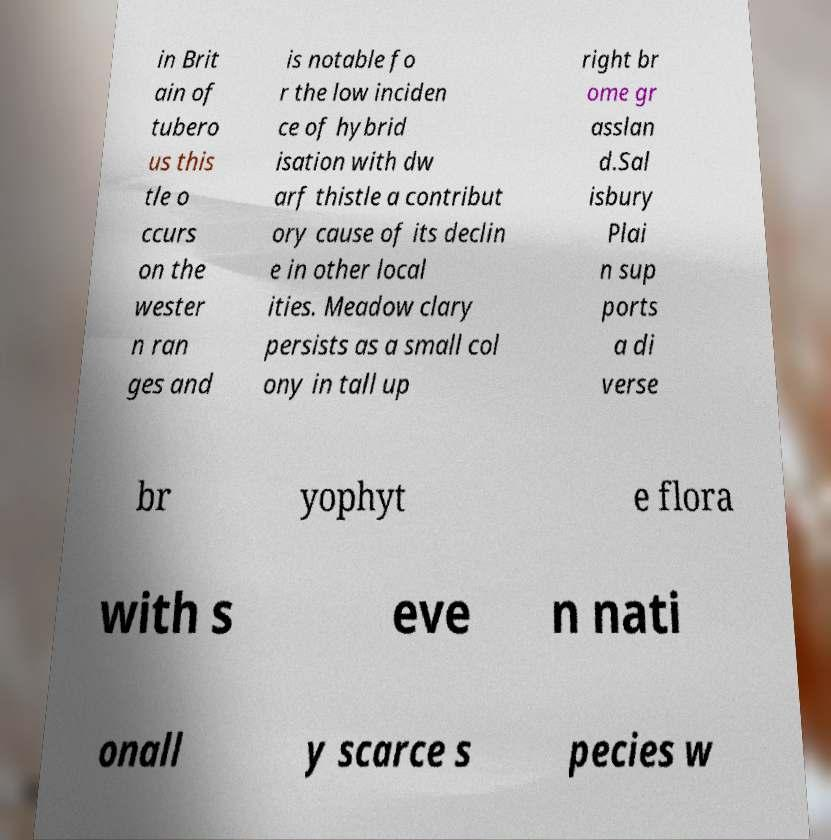Can you accurately transcribe the text from the provided image for me? in Brit ain of tubero us this tle o ccurs on the wester n ran ges and is notable fo r the low inciden ce of hybrid isation with dw arf thistle a contribut ory cause of its declin e in other local ities. Meadow clary persists as a small col ony in tall up right br ome gr asslan d.Sal isbury Plai n sup ports a di verse br yophyt e flora with s eve n nati onall y scarce s pecies w 